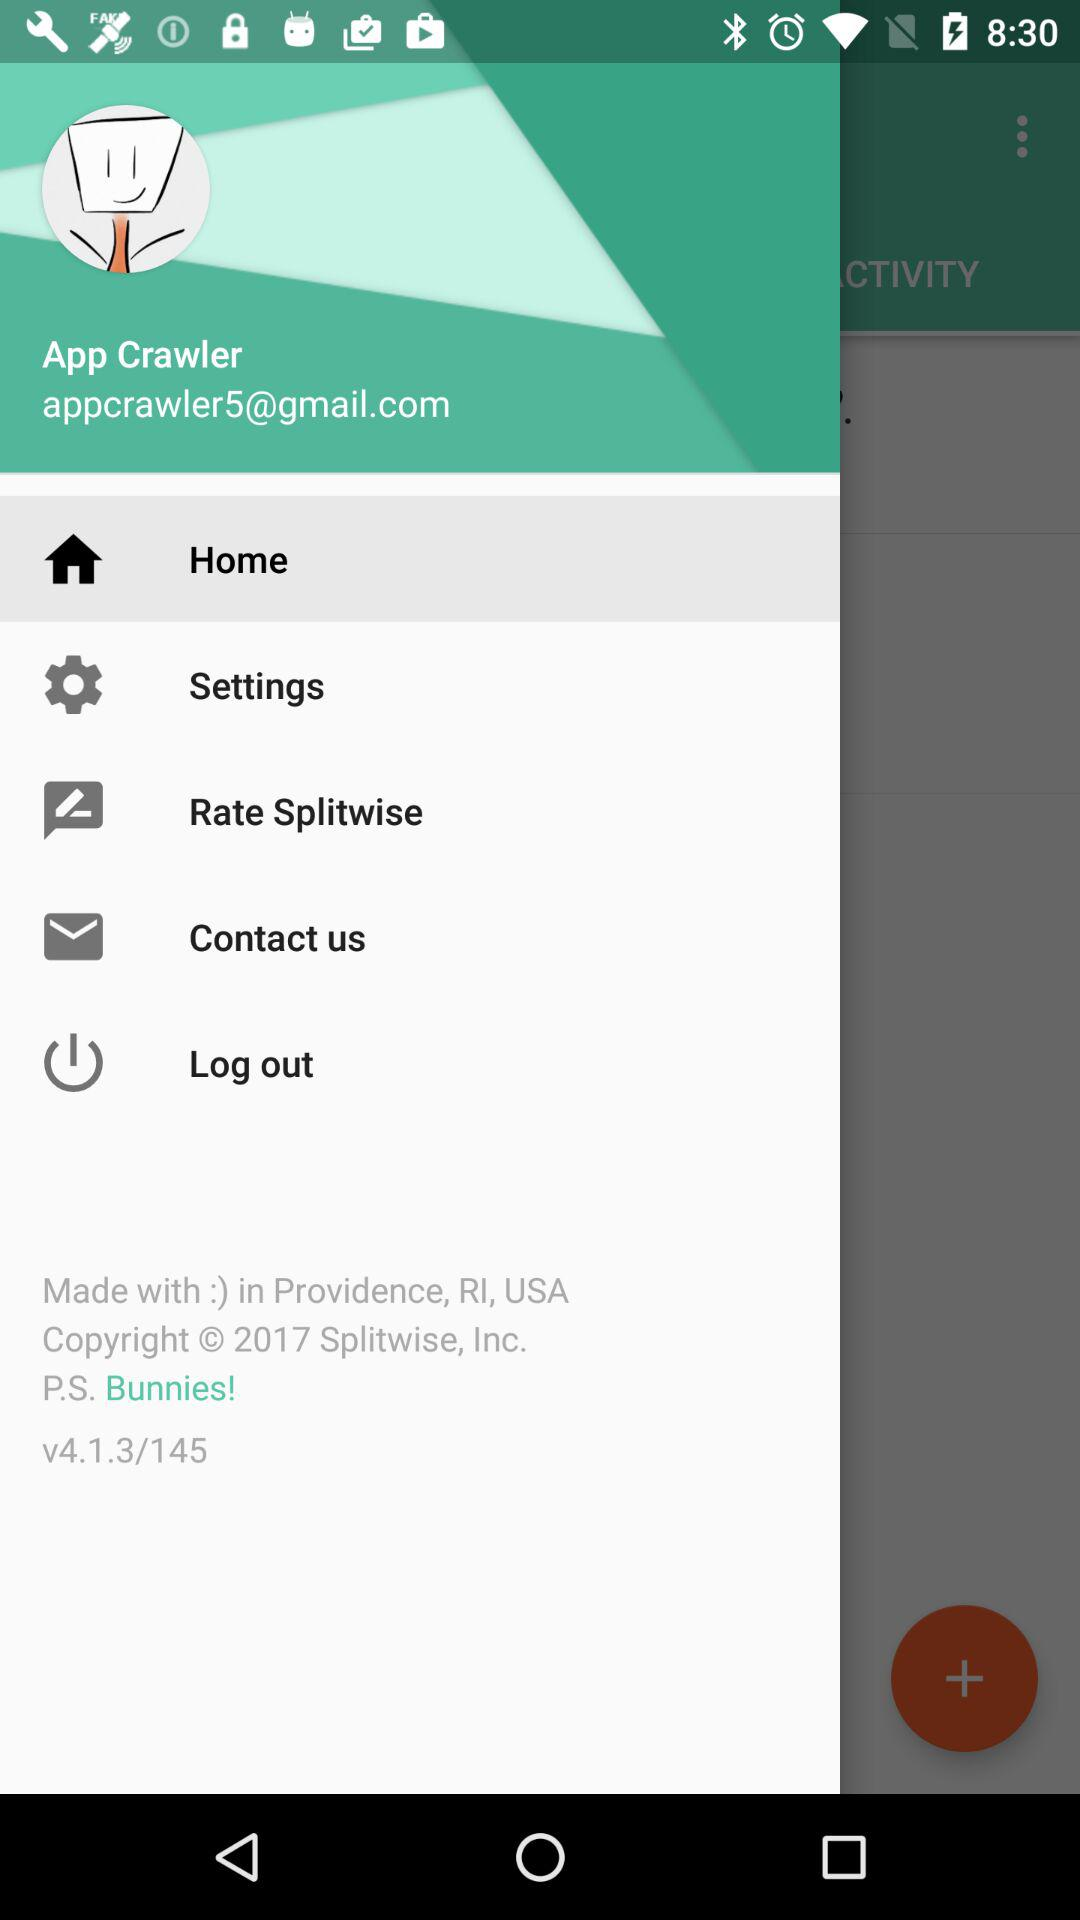Which item is selected? The selected item is "Home". 